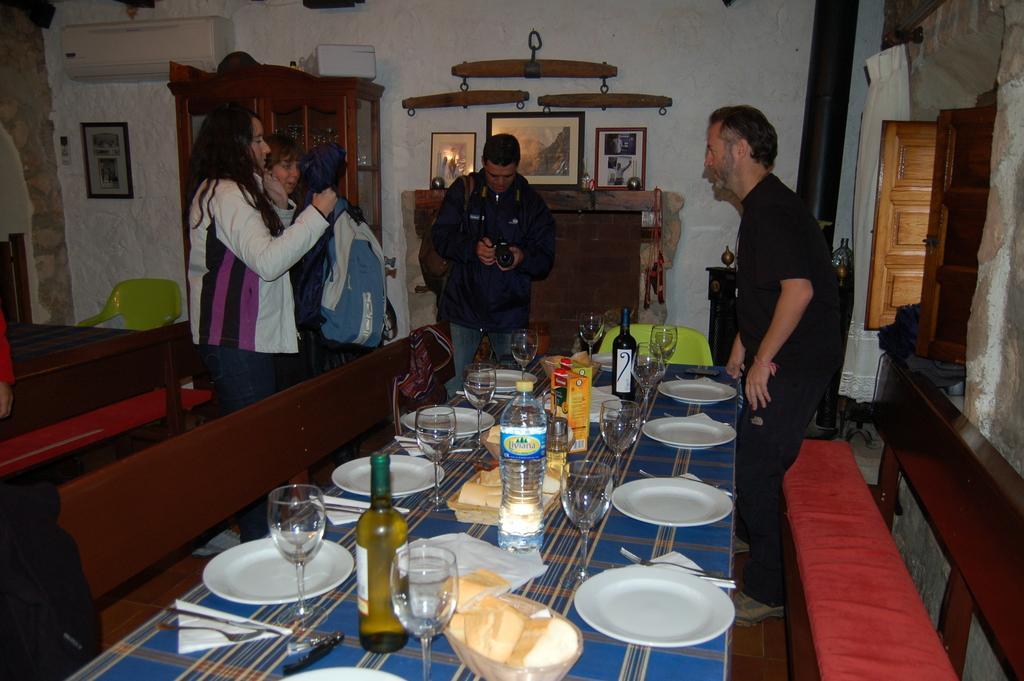Please provide a concise description of this image. In this picture we can see persons standing and some are holding bags and some are holding cameras and taking pictures and in front of them there is table and on table we can see bottle, glasses, tissue papers, plates beside to this table there is a chair and in the background we can see wall, frame, AC, pillar, wooden windows, curtain. 